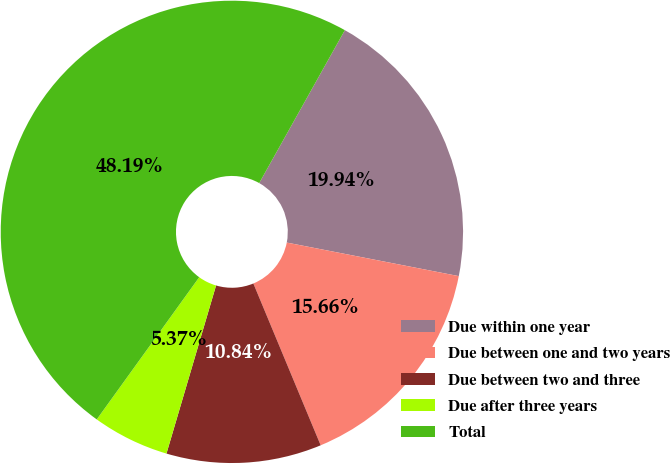Convert chart to OTSL. <chart><loc_0><loc_0><loc_500><loc_500><pie_chart><fcel>Due within one year<fcel>Due between one and two years<fcel>Due between two and three<fcel>Due after three years<fcel>Total<nl><fcel>19.94%<fcel>15.66%<fcel>10.84%<fcel>5.37%<fcel>48.19%<nl></chart> 